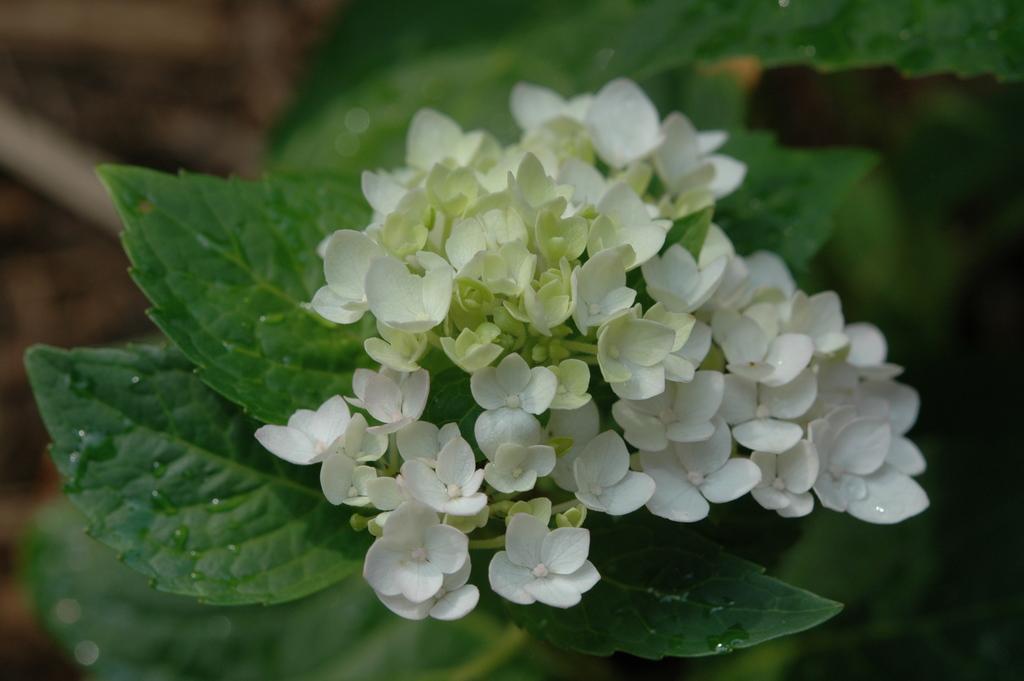Can you describe this image briefly? In this picture I can observe white color flowers. I can observe green color leaves. The background is completely blurred. 